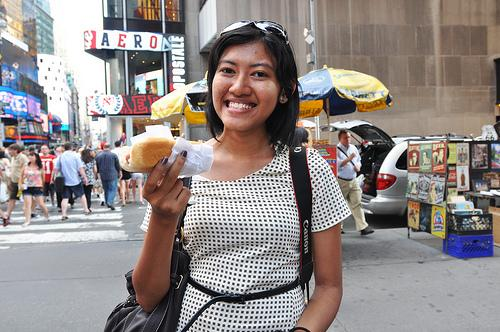What is the primary person in the image engaged in? The primary person, a woman, is engaged in holding a hot dog and smiling. In one sentence, describe the principal person in the image and their behavior. A cheerful woman with sunglasses on her head is holding a hot dog while a camera strap hangs on her shoulder. What is the main subject of the image doing? The main subject, a woman, is holding a hot dog and smiling. Provide a brief description of the central figure in the image and their current activity. A smiling woman holds a hot dog, with sunglasses resting on her head and a camera strap draped over her shoulder. Elaborate on the main individual in the image and what they are occupied with. The main individual is a happy woman with sunglasses on her head, holding a hot dog and wearing a camera strap on her shoulder. Describe the key figure in the image and their current action. The key figure is a woman who is holding a hot dog and smiling, with sunglasses on her head and a camera strap on her shoulder. Describe the central character in the image and their prominent features. The central character is a woman with sunglasses on her head, a camera strap on her shoulder, and holding a hot dog. Identify the primary focus of the image and describe their action. A woman is holding a hot dog and smiling, while wearing sunglasses on her head and a camera strap on her shoulder. Who is the central subject in the image and what are they doing? The central subject is a woman who is holding a hot dog, smiling, and wearing sunglasses on her head and a camera strap on her shoulder. Provide a summary of the main person in the image and their engagement. The main person in the image is a smiling woman holding a hot dog, with sunglasses on her head and a camera strap on her shoulder. 